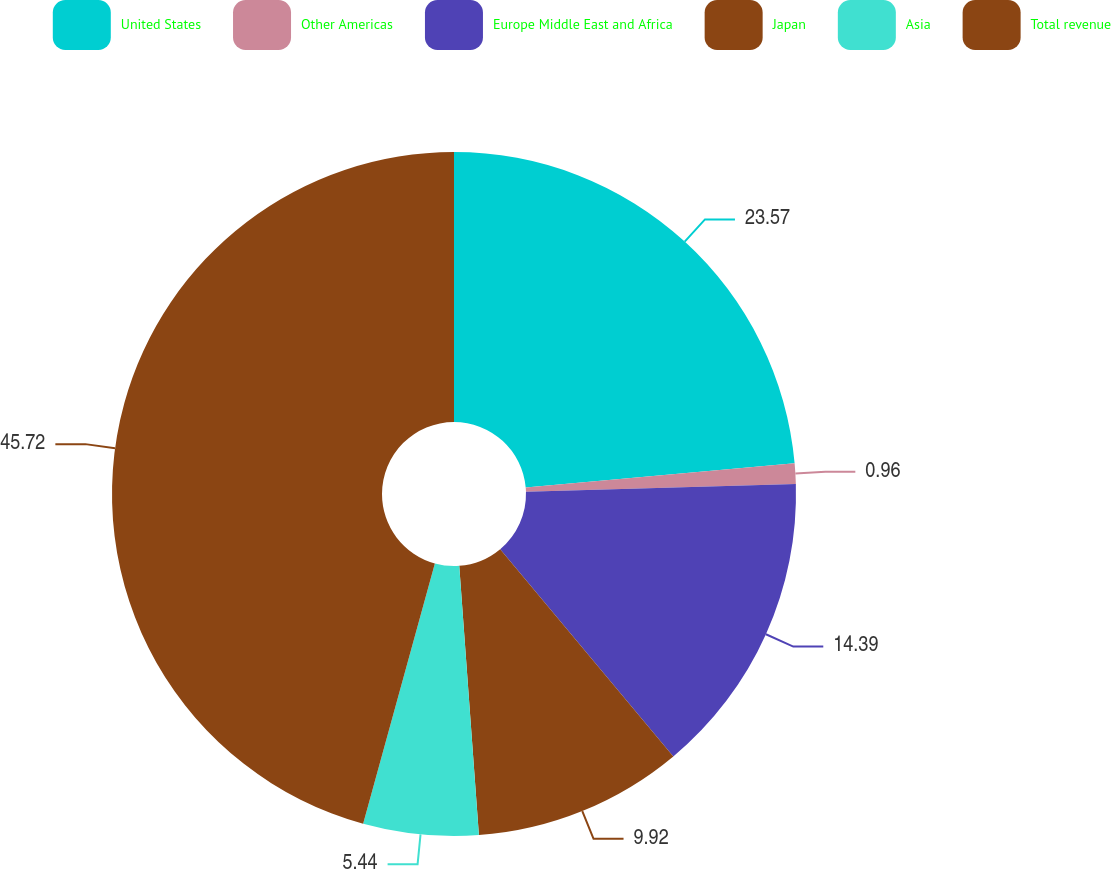Convert chart to OTSL. <chart><loc_0><loc_0><loc_500><loc_500><pie_chart><fcel>United States<fcel>Other Americas<fcel>Europe Middle East and Africa<fcel>Japan<fcel>Asia<fcel>Total revenue<nl><fcel>23.57%<fcel>0.96%<fcel>14.39%<fcel>9.92%<fcel>5.44%<fcel>45.72%<nl></chart> 